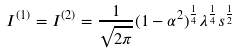Convert formula to latex. <formula><loc_0><loc_0><loc_500><loc_500>I ^ { ( 1 ) } = I ^ { ( 2 ) } = \frac { 1 } { \sqrt { 2 \pi } } ( 1 - \alpha ^ { 2 } ) ^ { \frac { 1 } { 4 } } \lambda ^ { \frac { 1 } { 4 } } s ^ { \frac { 1 } { 2 } }</formula> 